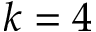<formula> <loc_0><loc_0><loc_500><loc_500>k = 4</formula> 